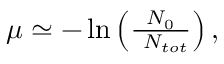<formula> <loc_0><loc_0><loc_500><loc_500>\begin{array} { r } { \mu \simeq - \ln \left ( \frac { N _ { 0 } } { \ N _ { t o t } } \right ) , } \end{array}</formula> 